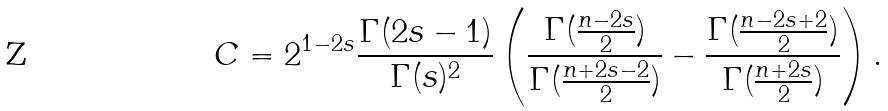<formula> <loc_0><loc_0><loc_500><loc_500>C = 2 ^ { 1 - 2 s } \frac { \Gamma ( 2 s - 1 ) } { \Gamma ( s ) ^ { 2 } } \left ( \frac { \Gamma ( \frac { n - 2 s } { 2 } ) } { \Gamma ( \frac { n + 2 s - 2 } { 2 } ) } - \frac { \Gamma ( \frac { n - 2 s + 2 } { 2 } ) } { \Gamma ( \frac { n + 2 s } { 2 } ) } \right ) .</formula> 